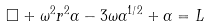Convert formula to latex. <formula><loc_0><loc_0><loc_500><loc_500>\Box + \omega ^ { 2 } r ^ { 2 } \alpha - 3 \omega \alpha ^ { 1 / 2 } + \alpha = L</formula> 